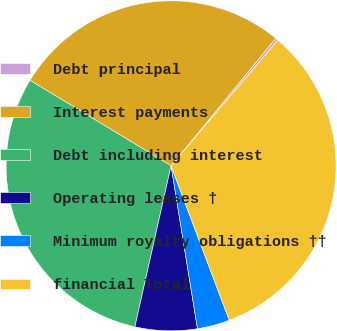Convert chart to OTSL. <chart><loc_0><loc_0><loc_500><loc_500><pie_chart><fcel>Debt principal<fcel>Interest payments<fcel>Debt including interest<fcel>Operating leases †<fcel>Minimum royalty obligations ††<fcel>financial Total<nl><fcel>0.27%<fcel>27.26%<fcel>30.16%<fcel>6.08%<fcel>3.18%<fcel>33.06%<nl></chart> 